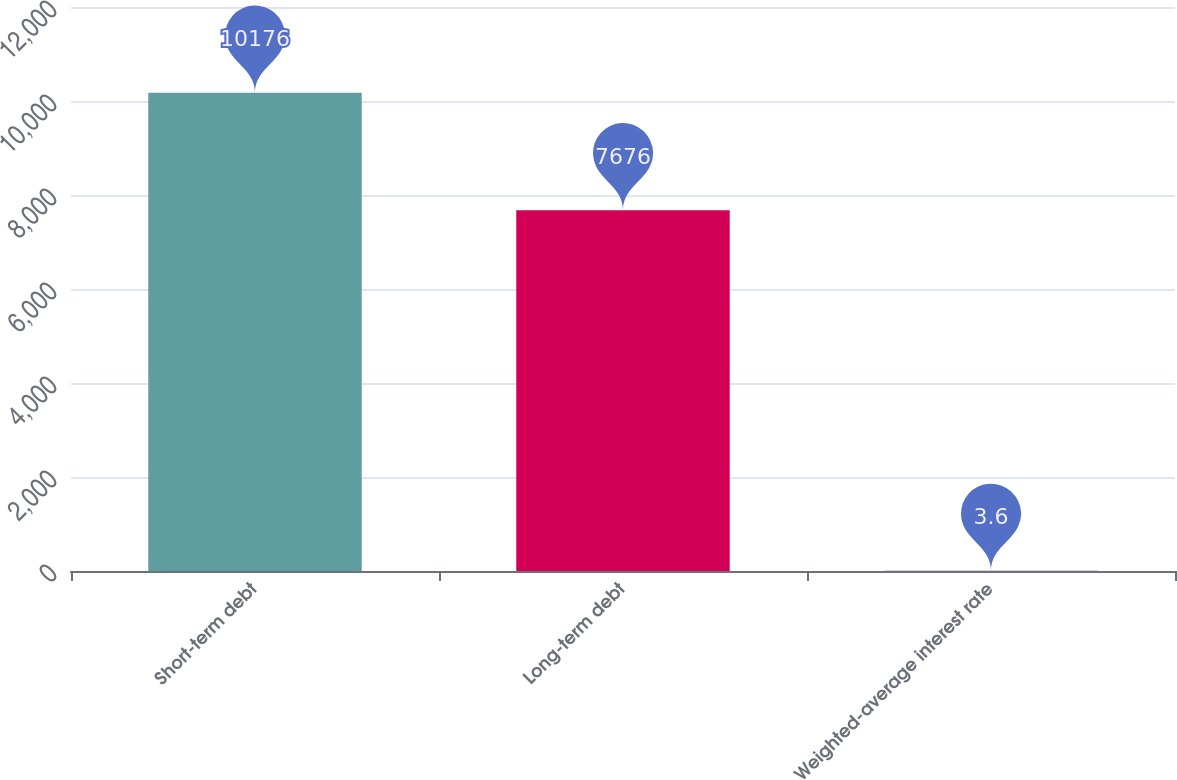Convert chart to OTSL. <chart><loc_0><loc_0><loc_500><loc_500><bar_chart><fcel>Short-term debt<fcel>Long-term debt<fcel>Weighted-average interest rate<nl><fcel>10176<fcel>7676<fcel>3.6<nl></chart> 